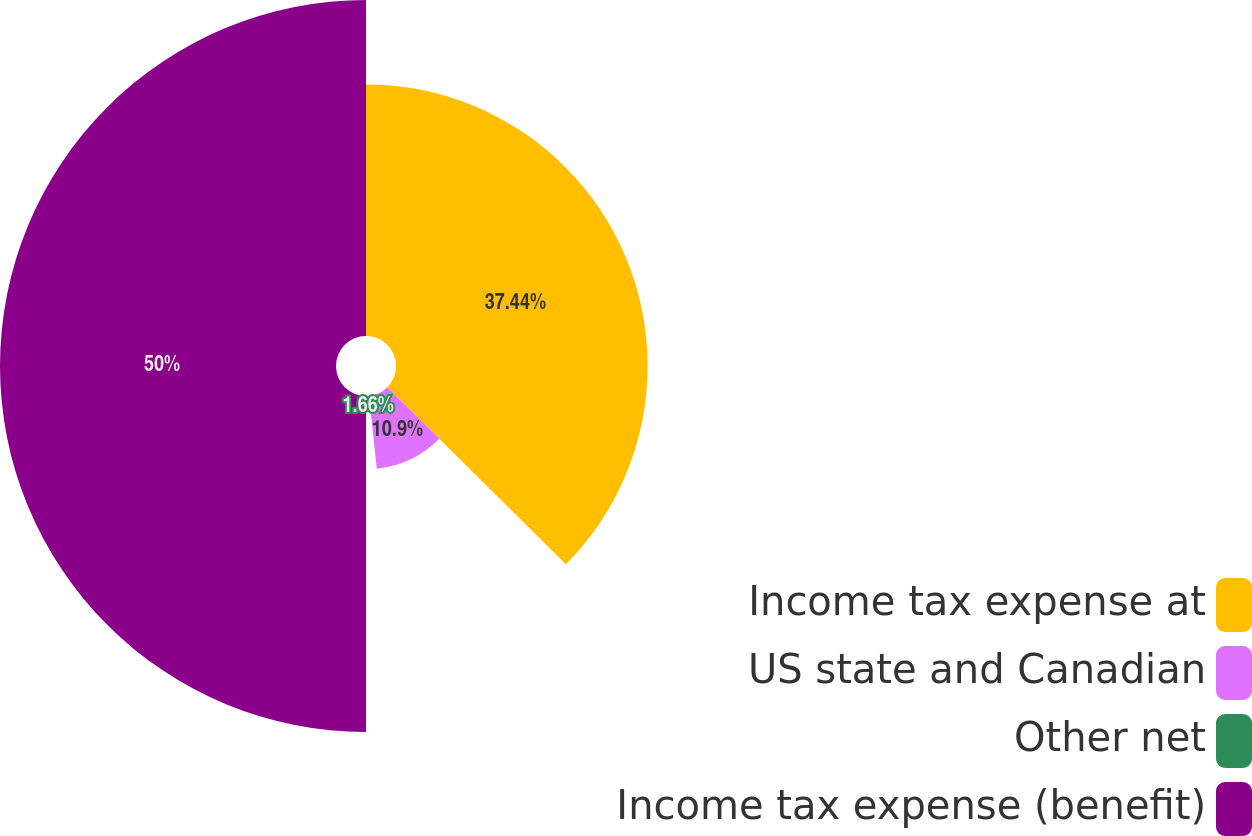Convert chart. <chart><loc_0><loc_0><loc_500><loc_500><pie_chart><fcel>Income tax expense at<fcel>US state and Canadian<fcel>Other net<fcel>Income tax expense (benefit)<nl><fcel>37.44%<fcel>10.9%<fcel>1.66%<fcel>50.0%<nl></chart> 